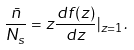Convert formula to latex. <formula><loc_0><loc_0><loc_500><loc_500>\frac { \bar { n } } { N _ { s } } = z \frac { d f ( z ) } { d z } | _ { z = 1 } .</formula> 